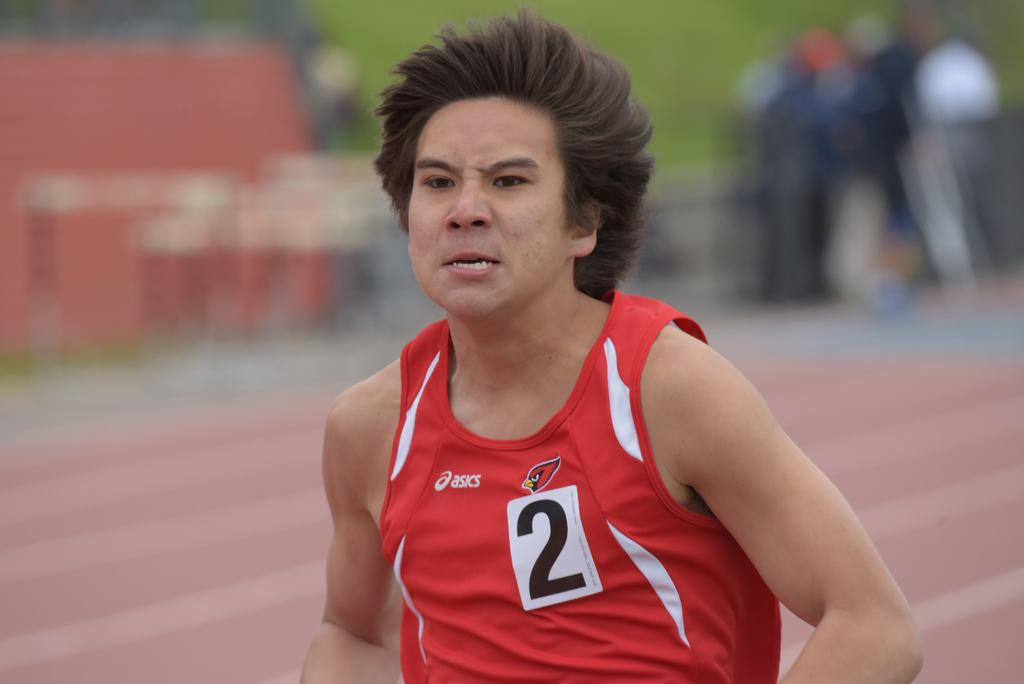<image>
Summarize the visual content of the image. a determined looking runner with a number 2 on his red vest 